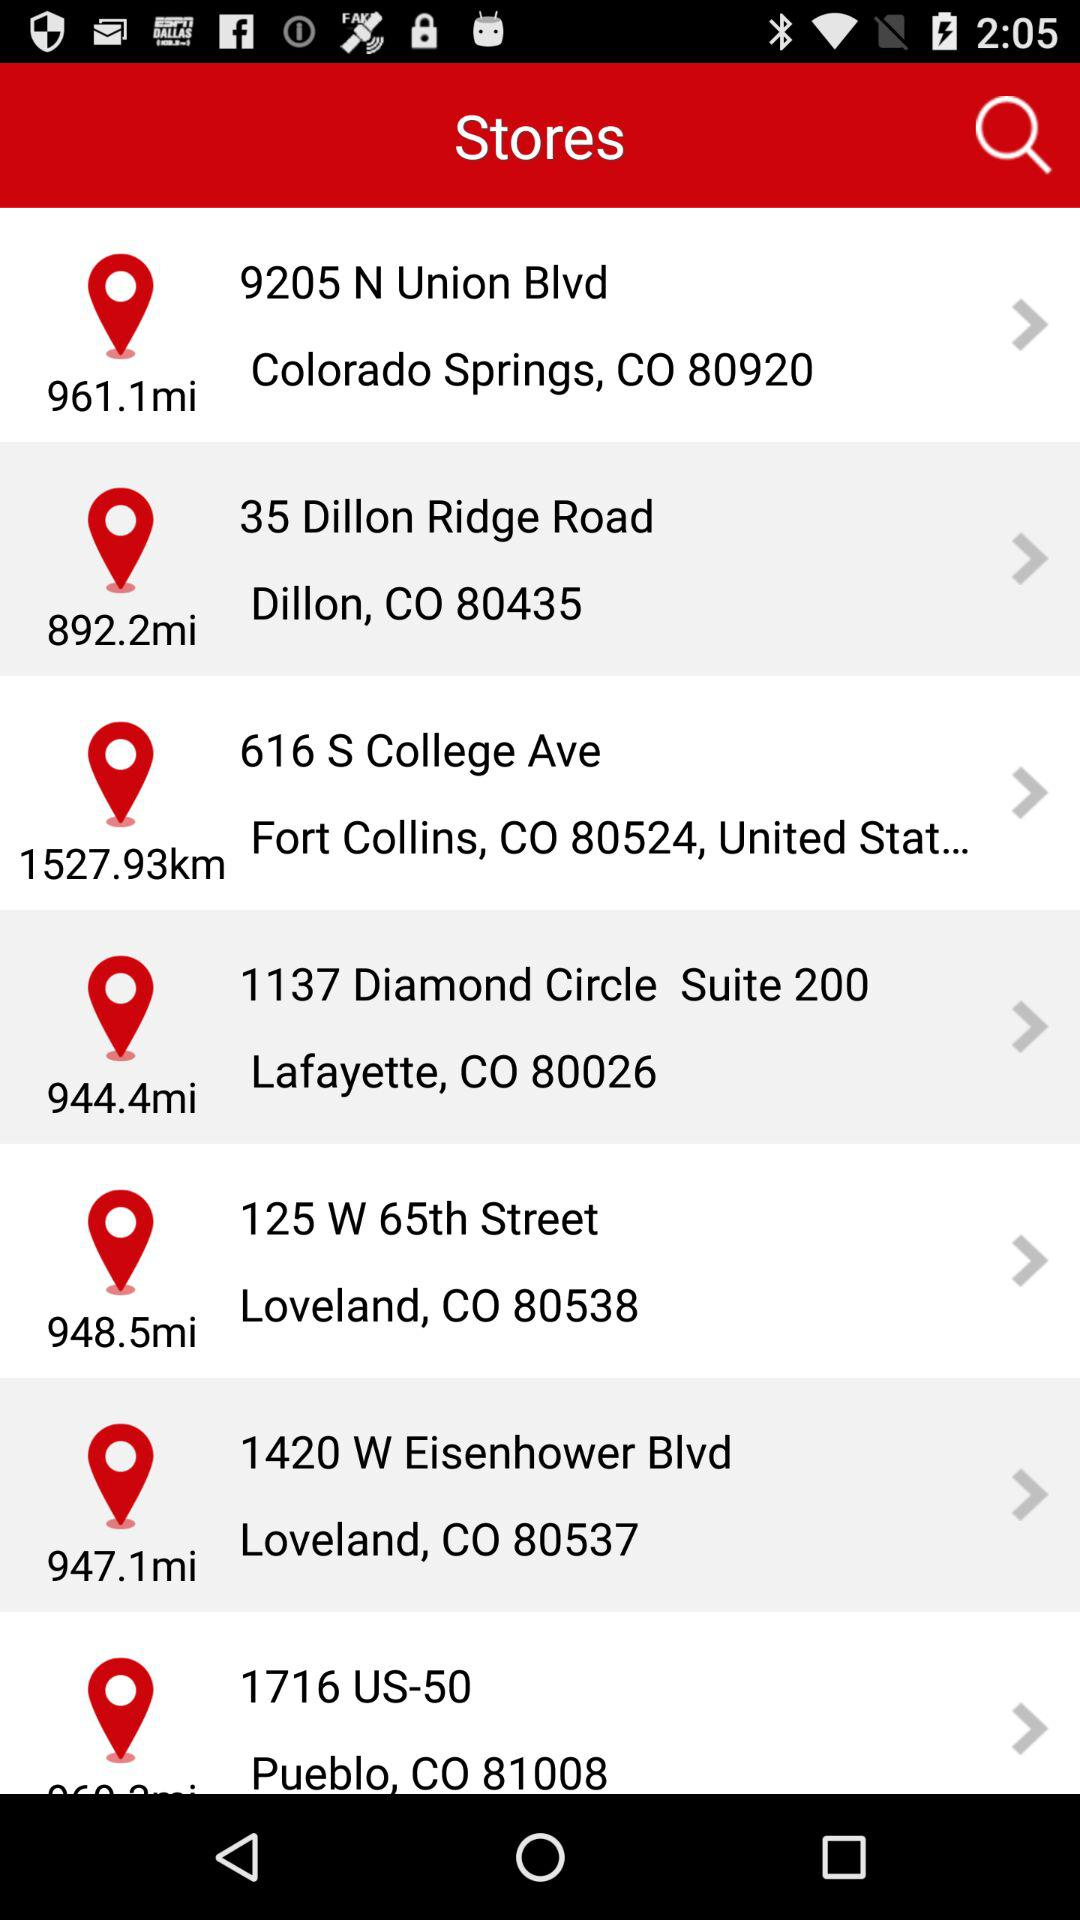Which store is 813.6 miles away?
When the provided information is insufficient, respond with <no answer>. <no answer> 